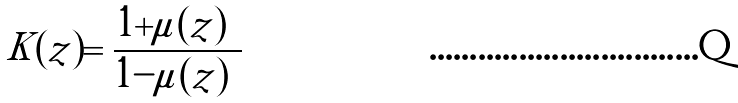Convert formula to latex. <formula><loc_0><loc_0><loc_500><loc_500>K ( z ) = \frac { 1 + | \mu ( z ) | } { 1 - | \mu ( z ) | }</formula> 